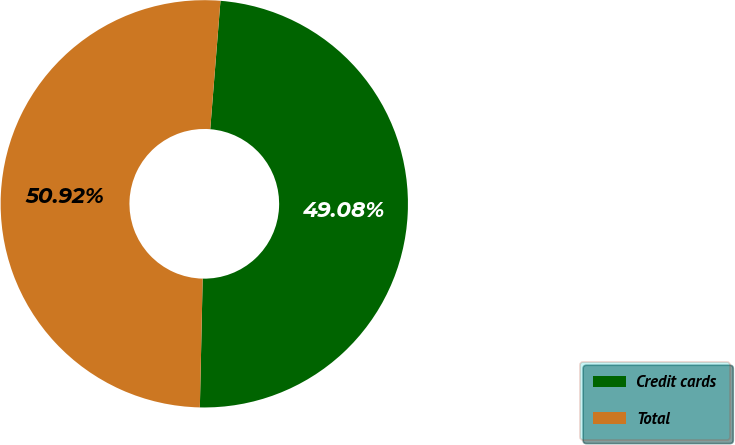Convert chart. <chart><loc_0><loc_0><loc_500><loc_500><pie_chart><fcel>Credit cards<fcel>Total<nl><fcel>49.08%<fcel>50.92%<nl></chart> 